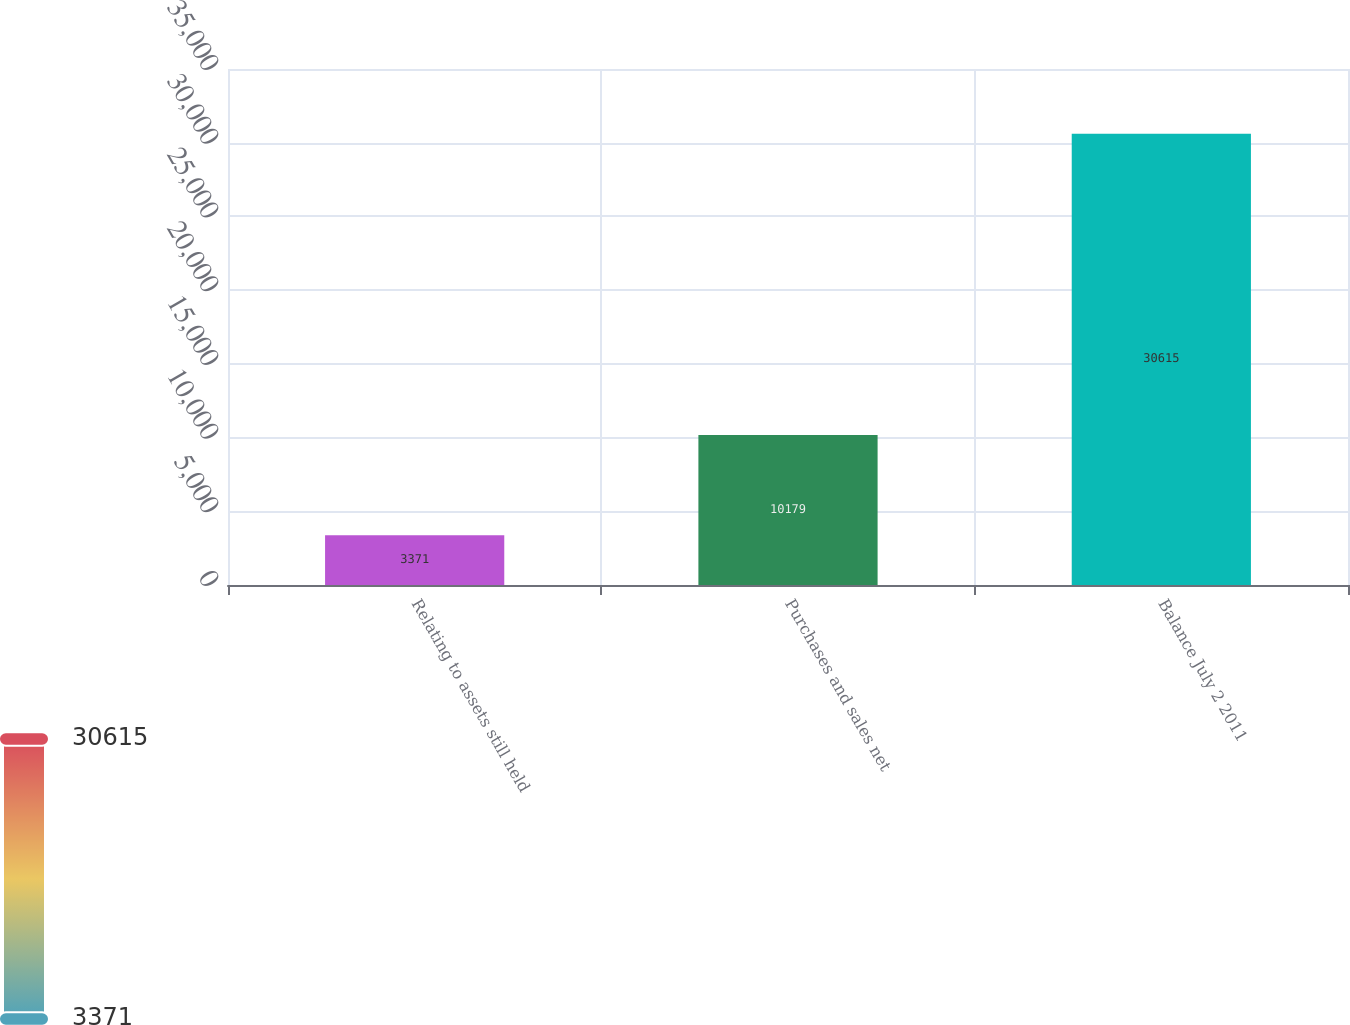Convert chart to OTSL. <chart><loc_0><loc_0><loc_500><loc_500><bar_chart><fcel>Relating to assets still held<fcel>Purchases and sales net<fcel>Balance July 2 2011<nl><fcel>3371<fcel>10179<fcel>30615<nl></chart> 